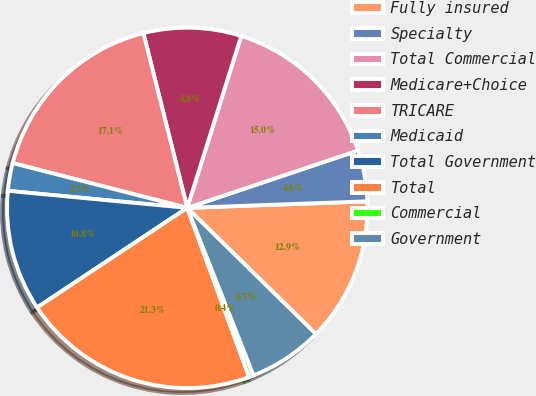Convert chart to OTSL. <chart><loc_0><loc_0><loc_500><loc_500><pie_chart><fcel>Fully insured<fcel>Specialty<fcel>Total Commercial<fcel>Medicare+Choice<fcel>TRICARE<fcel>Medicaid<fcel>Total Government<fcel>Total<fcel>Commercial<fcel>Government<nl><fcel>12.92%<fcel>4.58%<fcel>15.0%<fcel>8.75%<fcel>17.09%<fcel>2.49%<fcel>10.83%<fcel>21.26%<fcel>0.41%<fcel>6.66%<nl></chart> 